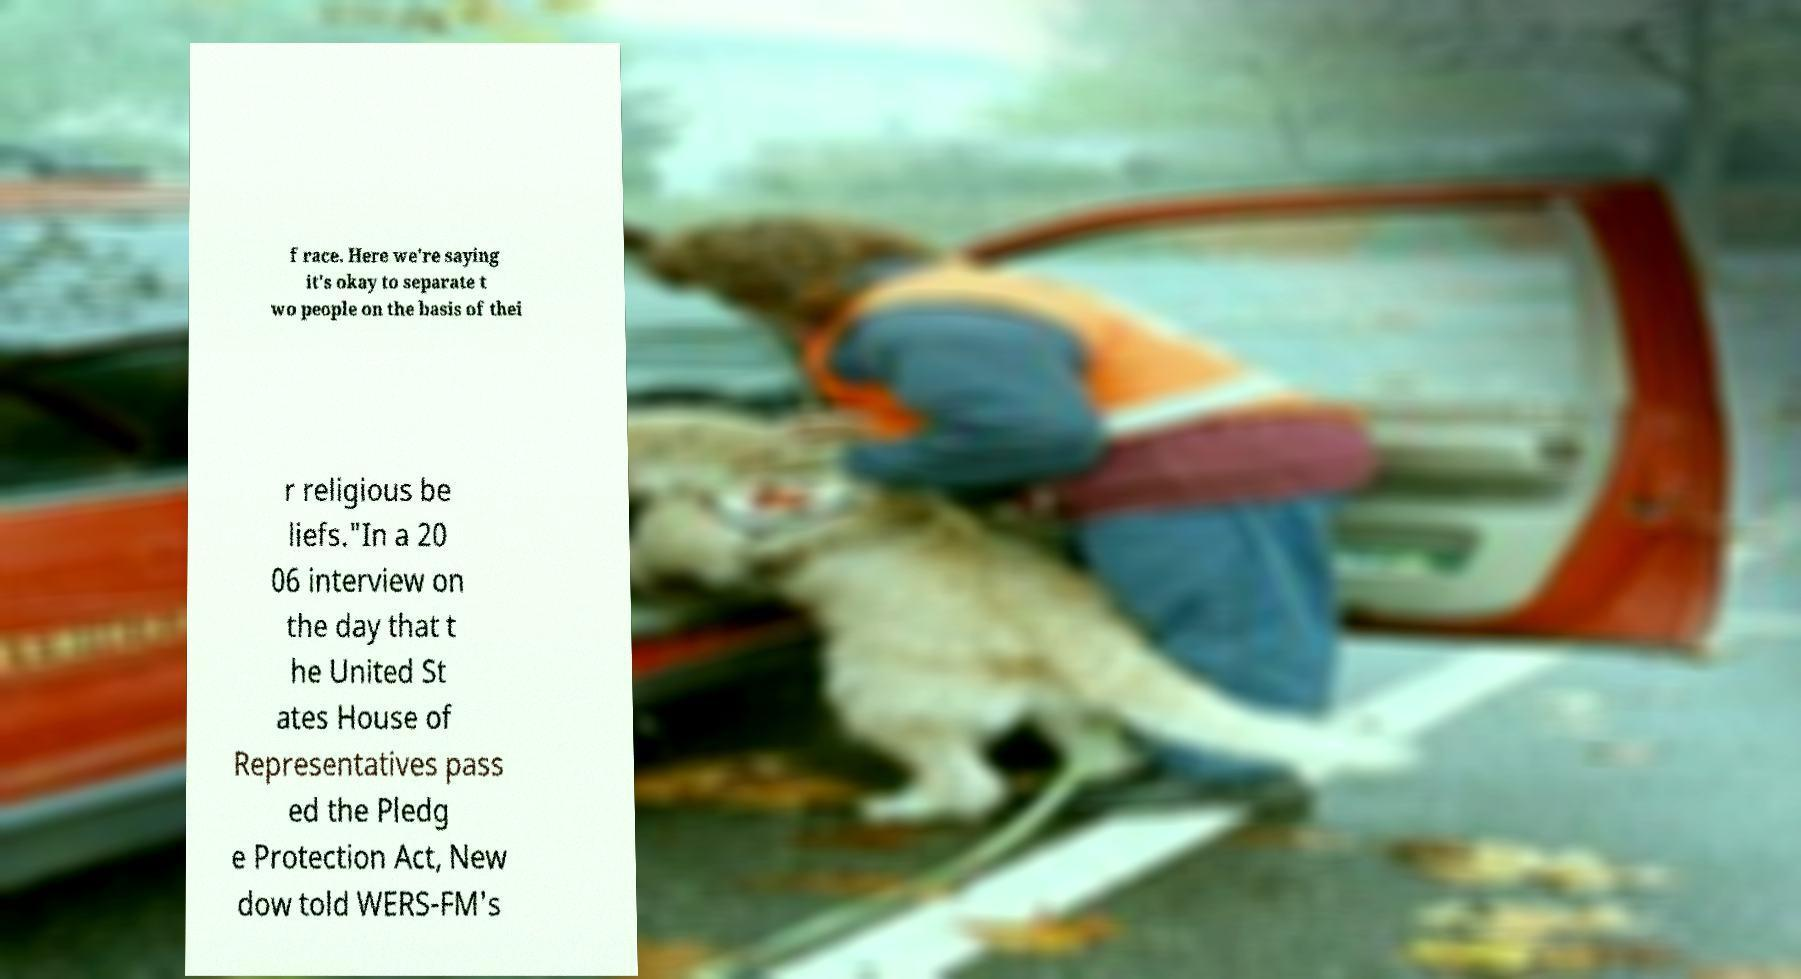Could you assist in decoding the text presented in this image and type it out clearly? f race. Here we're saying it's okay to separate t wo people on the basis of thei r religious be liefs."In a 20 06 interview on the day that t he United St ates House of Representatives pass ed the Pledg e Protection Act, New dow told WERS-FM's 